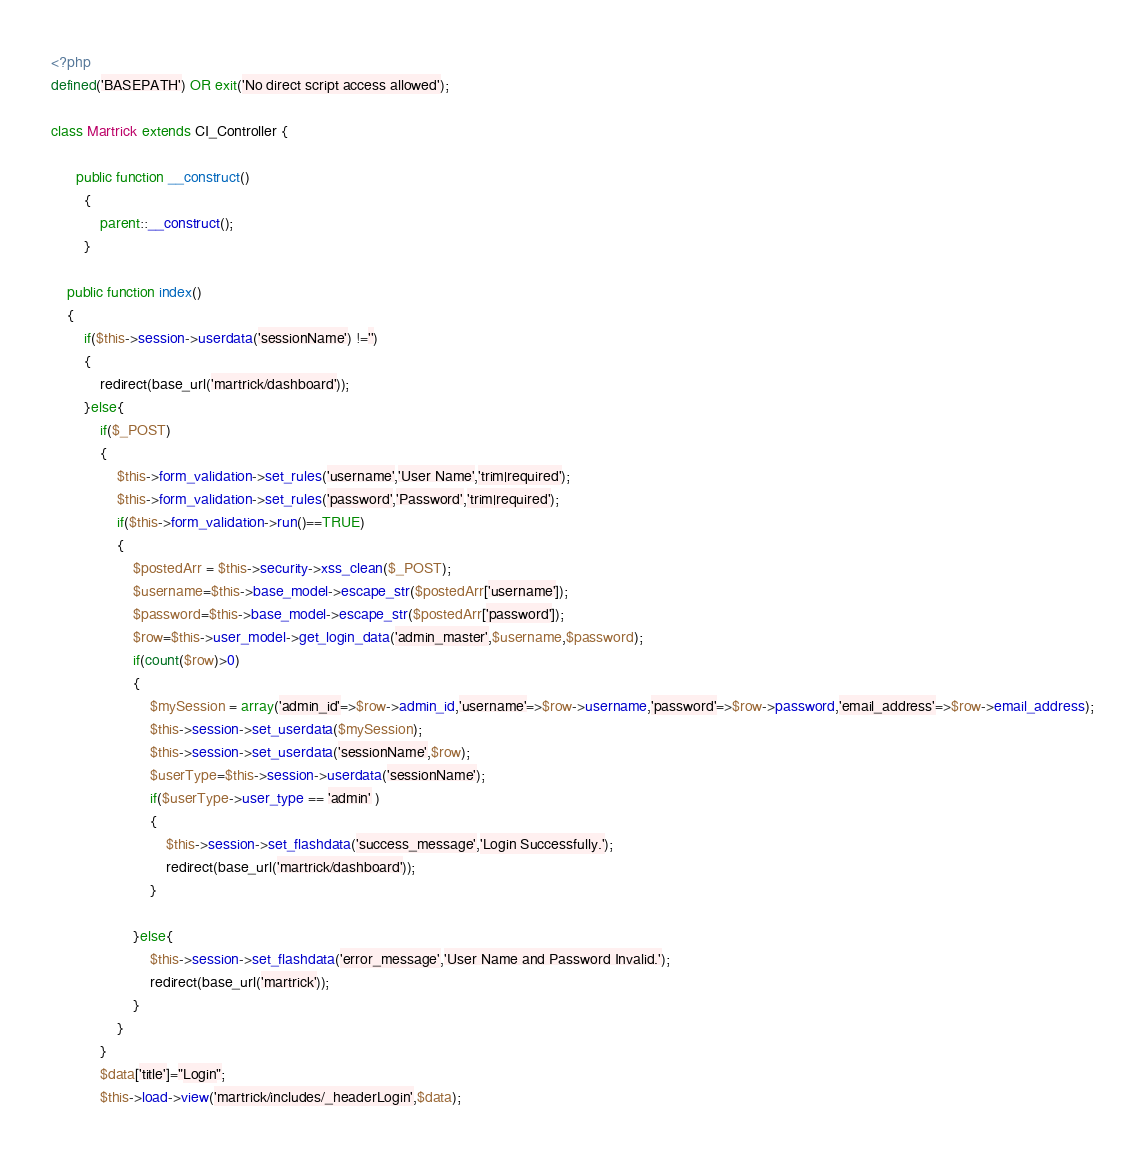Convert code to text. <code><loc_0><loc_0><loc_500><loc_500><_PHP_><?php
defined('BASEPATH') OR exit('No direct script access allowed');

class Martrick extends CI_Controller {

	  public function __construct()
        {
			parent::__construct();
        }
		
	public function index()
	{
		if($this->session->userdata('sessionName') !='')
		{
			redirect(base_url('martrick/dashboard'));
		}else{
			if($_POST)
			{
				$this->form_validation->set_rules('username','User Name','trim|required');
				$this->form_validation->set_rules('password','Password','trim|required');
				if($this->form_validation->run()==TRUE)
				{
					$postedArr = $this->security->xss_clean($_POST);
					$username=$this->base_model->escape_str($postedArr['username']);
					$password=$this->base_model->escape_str($postedArr['password']);
					$row=$this->user_model->get_login_data('admin_master',$username,$password);
					if(count($row)>0)
					{
						$mySession = array('admin_id'=>$row->admin_id,'username'=>$row->username,'password'=>$row->password,'email_address'=>$row->email_address);
						$this->session->set_userdata($mySession);
						$this->session->set_userdata('sessionName',$row);
						$userType=$this->session->userdata('sessionName');
						if($userType->user_type == 'admin' )
						{ 	
							$this->session->set_flashdata('success_message','Login Successfully.');
							redirect(base_url('martrick/dashboard'));
						}
						
					}else{
						$this->session->set_flashdata('error_message','User Name and Password Invalid.');
						redirect(base_url('martrick'));
					}
				}	
			}
			$data['title']="Login";
			$this->load->view('martrick/includes/_headerLogin',$data);</code> 